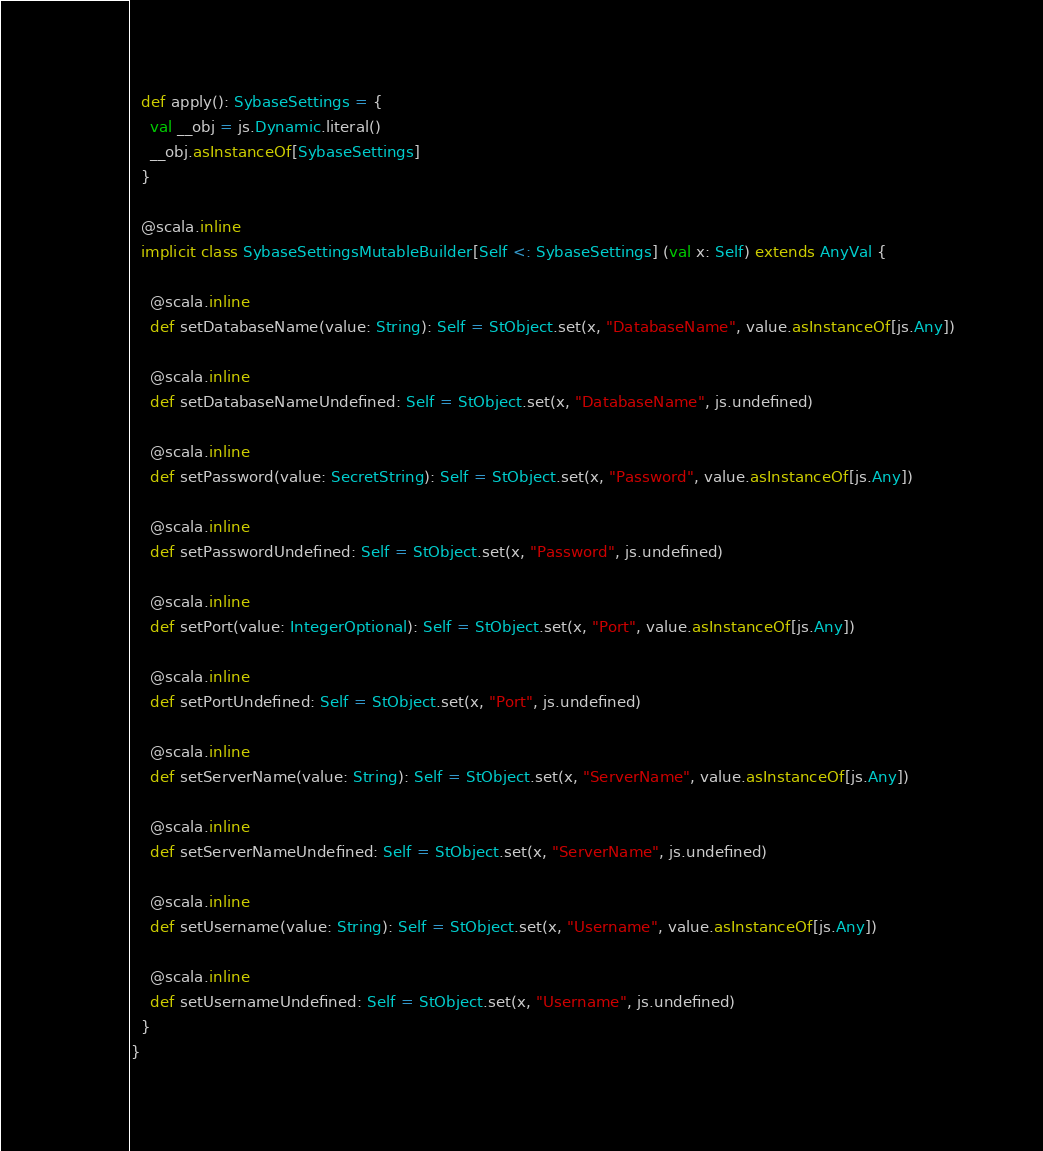Convert code to text. <code><loc_0><loc_0><loc_500><loc_500><_Scala_>  def apply(): SybaseSettings = {
    val __obj = js.Dynamic.literal()
    __obj.asInstanceOf[SybaseSettings]
  }
  
  @scala.inline
  implicit class SybaseSettingsMutableBuilder[Self <: SybaseSettings] (val x: Self) extends AnyVal {
    
    @scala.inline
    def setDatabaseName(value: String): Self = StObject.set(x, "DatabaseName", value.asInstanceOf[js.Any])
    
    @scala.inline
    def setDatabaseNameUndefined: Self = StObject.set(x, "DatabaseName", js.undefined)
    
    @scala.inline
    def setPassword(value: SecretString): Self = StObject.set(x, "Password", value.asInstanceOf[js.Any])
    
    @scala.inline
    def setPasswordUndefined: Self = StObject.set(x, "Password", js.undefined)
    
    @scala.inline
    def setPort(value: IntegerOptional): Self = StObject.set(x, "Port", value.asInstanceOf[js.Any])
    
    @scala.inline
    def setPortUndefined: Self = StObject.set(x, "Port", js.undefined)
    
    @scala.inline
    def setServerName(value: String): Self = StObject.set(x, "ServerName", value.asInstanceOf[js.Any])
    
    @scala.inline
    def setServerNameUndefined: Self = StObject.set(x, "ServerName", js.undefined)
    
    @scala.inline
    def setUsername(value: String): Self = StObject.set(x, "Username", value.asInstanceOf[js.Any])
    
    @scala.inline
    def setUsernameUndefined: Self = StObject.set(x, "Username", js.undefined)
  }
}
</code> 